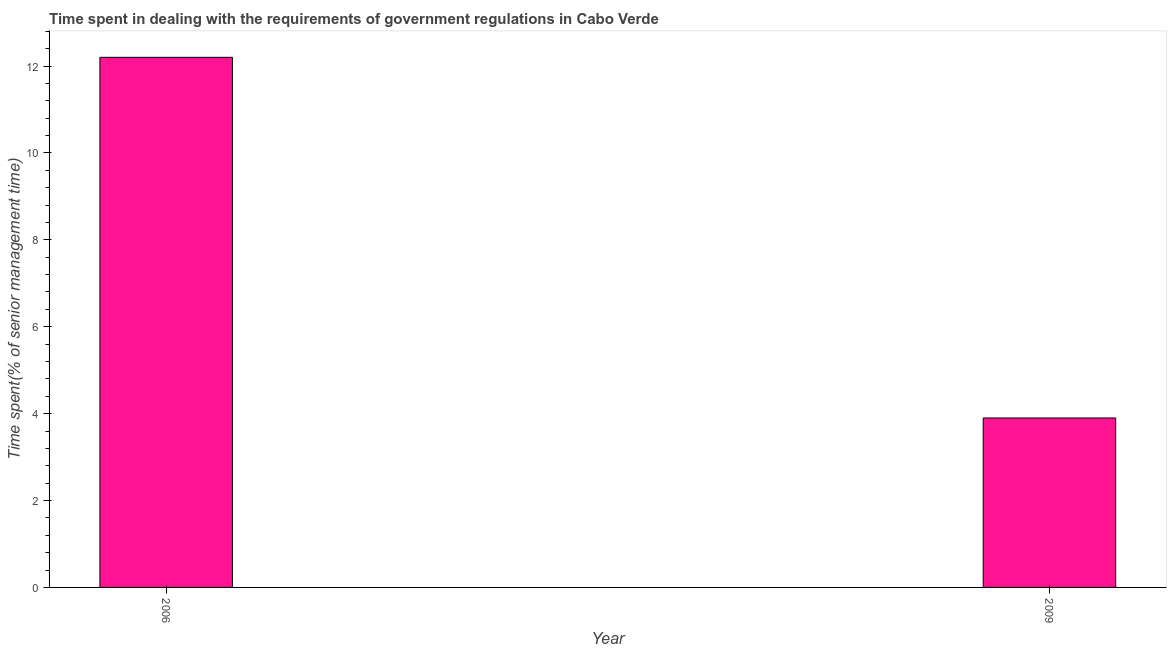Does the graph contain any zero values?
Give a very brief answer. No. Does the graph contain grids?
Give a very brief answer. No. What is the title of the graph?
Provide a succinct answer. Time spent in dealing with the requirements of government regulations in Cabo Verde. What is the label or title of the X-axis?
Offer a very short reply. Year. What is the label or title of the Y-axis?
Your answer should be compact. Time spent(% of senior management time). Across all years, what is the maximum time spent in dealing with government regulations?
Make the answer very short. 12.2. What is the sum of the time spent in dealing with government regulations?
Offer a terse response. 16.1. What is the average time spent in dealing with government regulations per year?
Your answer should be compact. 8.05. What is the median time spent in dealing with government regulations?
Ensure brevity in your answer.  8.05. In how many years, is the time spent in dealing with government regulations greater than 11.2 %?
Give a very brief answer. 1. What is the ratio of the time spent in dealing with government regulations in 2006 to that in 2009?
Your response must be concise. 3.13. In how many years, is the time spent in dealing with government regulations greater than the average time spent in dealing with government regulations taken over all years?
Offer a very short reply. 1. How many bars are there?
Your answer should be very brief. 2. Are all the bars in the graph horizontal?
Make the answer very short. No. How many years are there in the graph?
Your response must be concise. 2. Are the values on the major ticks of Y-axis written in scientific E-notation?
Offer a terse response. No. What is the difference between the Time spent(% of senior management time) in 2006 and 2009?
Make the answer very short. 8.3. What is the ratio of the Time spent(% of senior management time) in 2006 to that in 2009?
Your response must be concise. 3.13. 